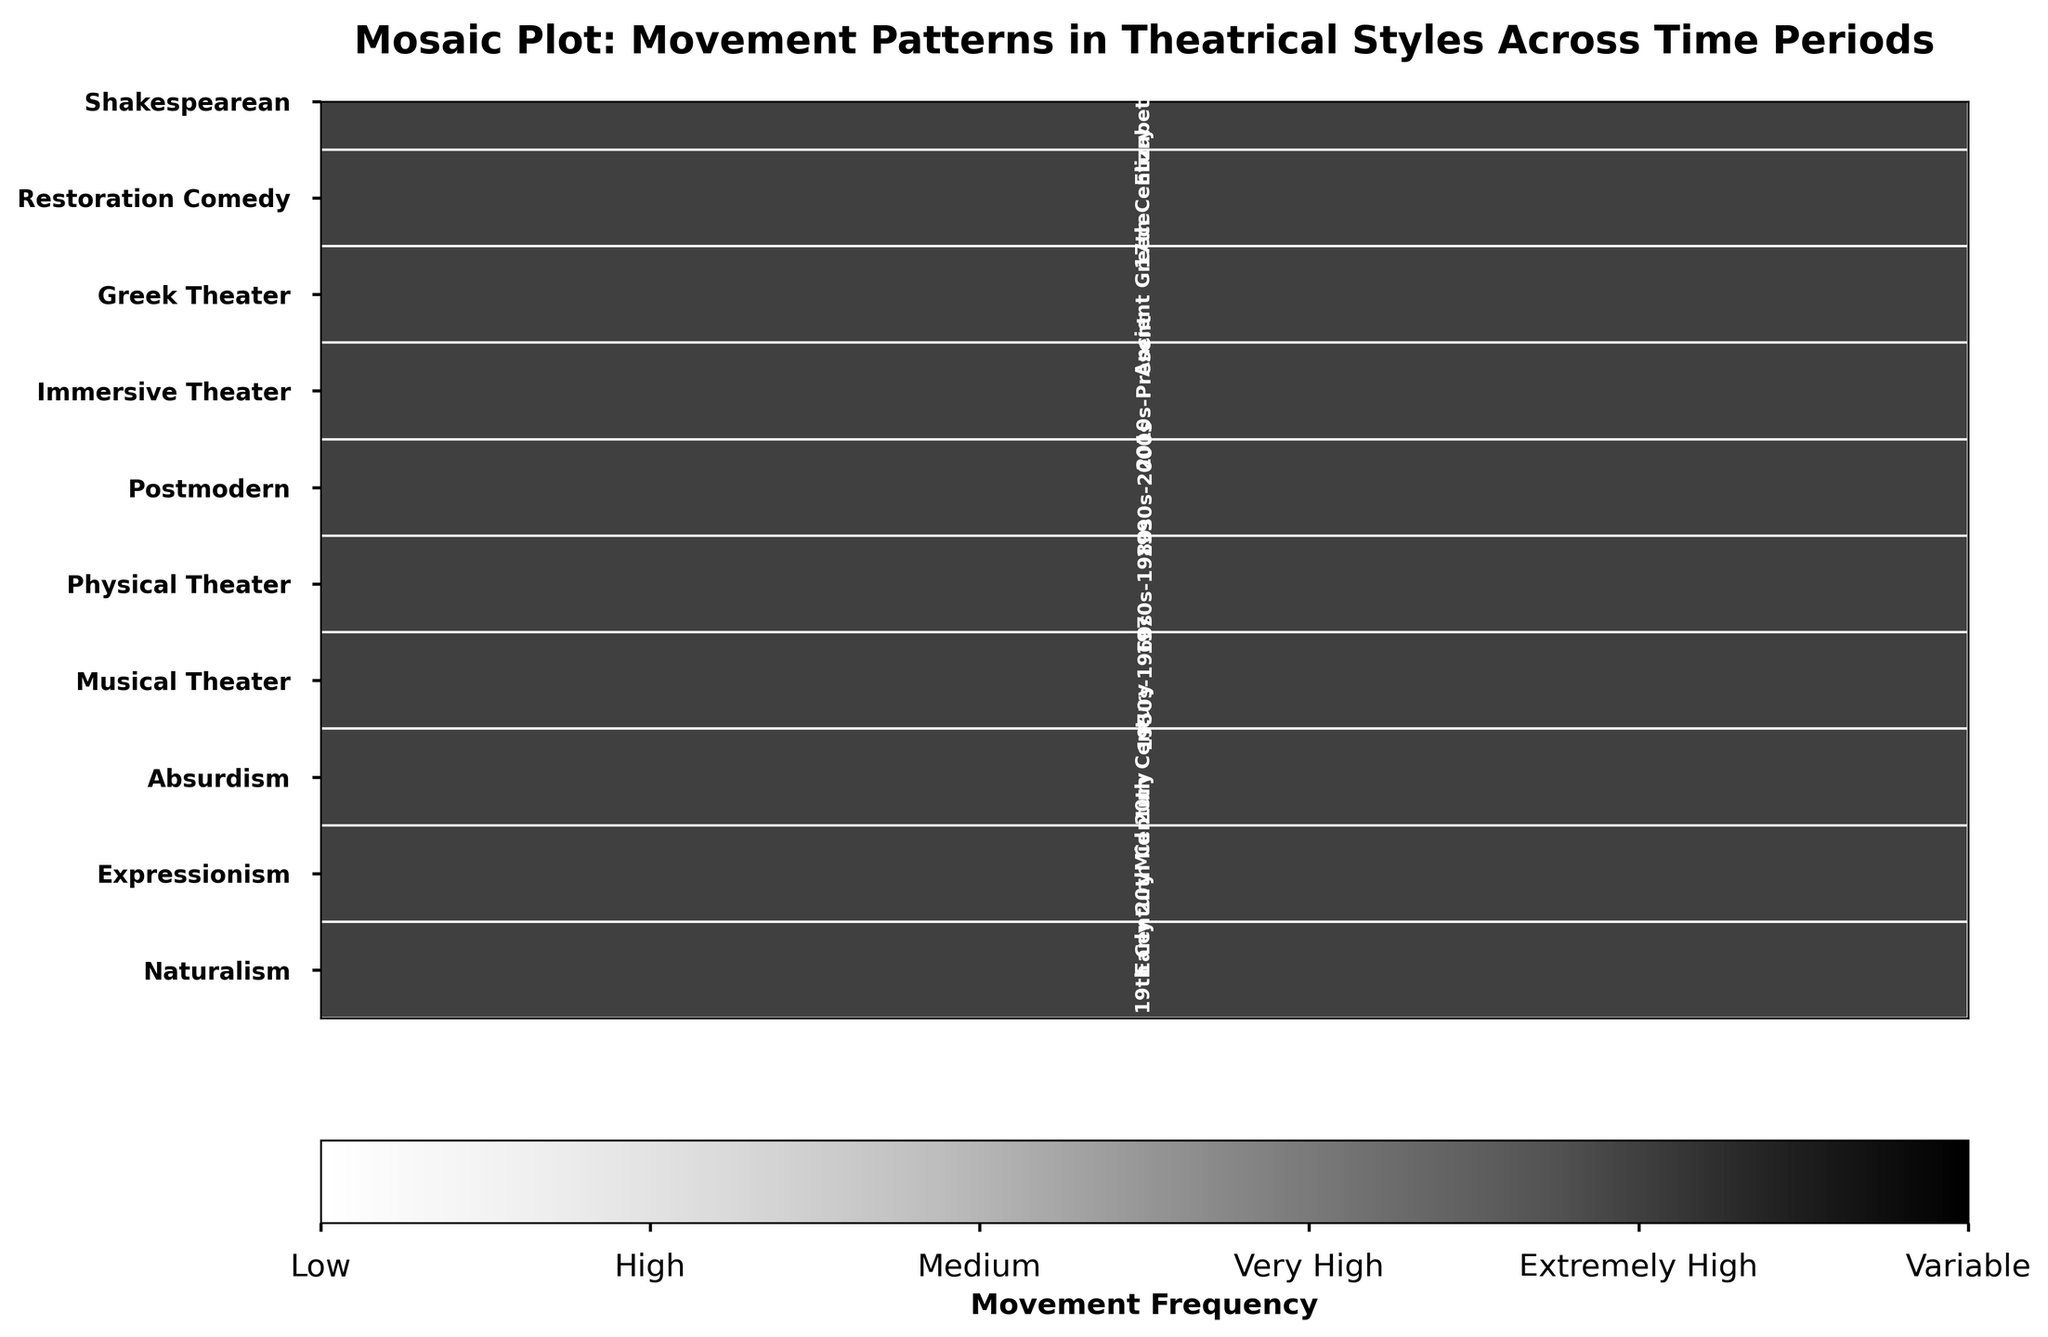What's the title of the figure? The title is displayed at the top center of the figure. By looking at the top, we can read the title directly.
Answer: Mosaic Plot: Movement Patterns in Theatrical Styles Across Time Periods Which theatrical style has the highest movement frequency? By examining the color bar and matching the darkest shade in the plot, we can identify which block represents the highest movement frequency and see the corresponding theatrical style on the y-axis.
Answer: Physical Theater Which time periods are associated with the Naturalism theatrical style? We locate the Naturalism style on the y-axis and then identify the corresponding time periods labeled inside the block(s) horizontally.
Answer: Late 19th Century How does the movement frequency of Musical Theater in the 1950s-1960s compare to that of Immersive Theater from the 2010s-Present? We find the respective time periods in the row of Musical Theater and Immersive Theater, then compare their color intensity. Musical Theater is "Very High" (darker shade) compared to Immersive Theater’s "High" (lighter shade).
Answer: Musical Theater has a higher movement frequency Which theatrical style spans multiple time periods? We identify which style has multiple blocks horizontally, each corresponding to a different time period.
Answer: None What is the predominant movement pattern of Absurdism, and how frequent is its movement? We look for Absurdism in the y-axis, then move horizontally to locate its block and read its color intensity and associated time period. The text description specifies movement pattern. According to the data, "Medium" frequency translates to repetitive actions.
Answer: Repetitive actions, Medium In which theatrical style is the movement described as "stylized poses"? Locate the description "stylized poses" from the predominant pattern column, and then relate it to the corresponding theatrical style.
Answer: Greek Theater How do the movement frequencies compare between Greek Theater and Restoration Comedy? Identify the colors corresponding to these two styles and compare their intensities. Both have medium frequency, thus similar color shades.
Answer: They are the same Which theatrical style has the most variable movement frequency? By examining the colorbars and identifying the style labeled "Variable," we find it in the time period column.
Answer: Postmodern Which theatrical styles have a "High" movement frequency? Locate blocks with similar color intensities corresponding to "High" movement frequency and identify their associated styles from the y-axis.
Answer: Expressionism, Immersive Theater, Shakespearean 